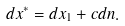<formula> <loc_0><loc_0><loc_500><loc_500>d x ^ { * } = d x _ { 1 } + c d n .</formula> 